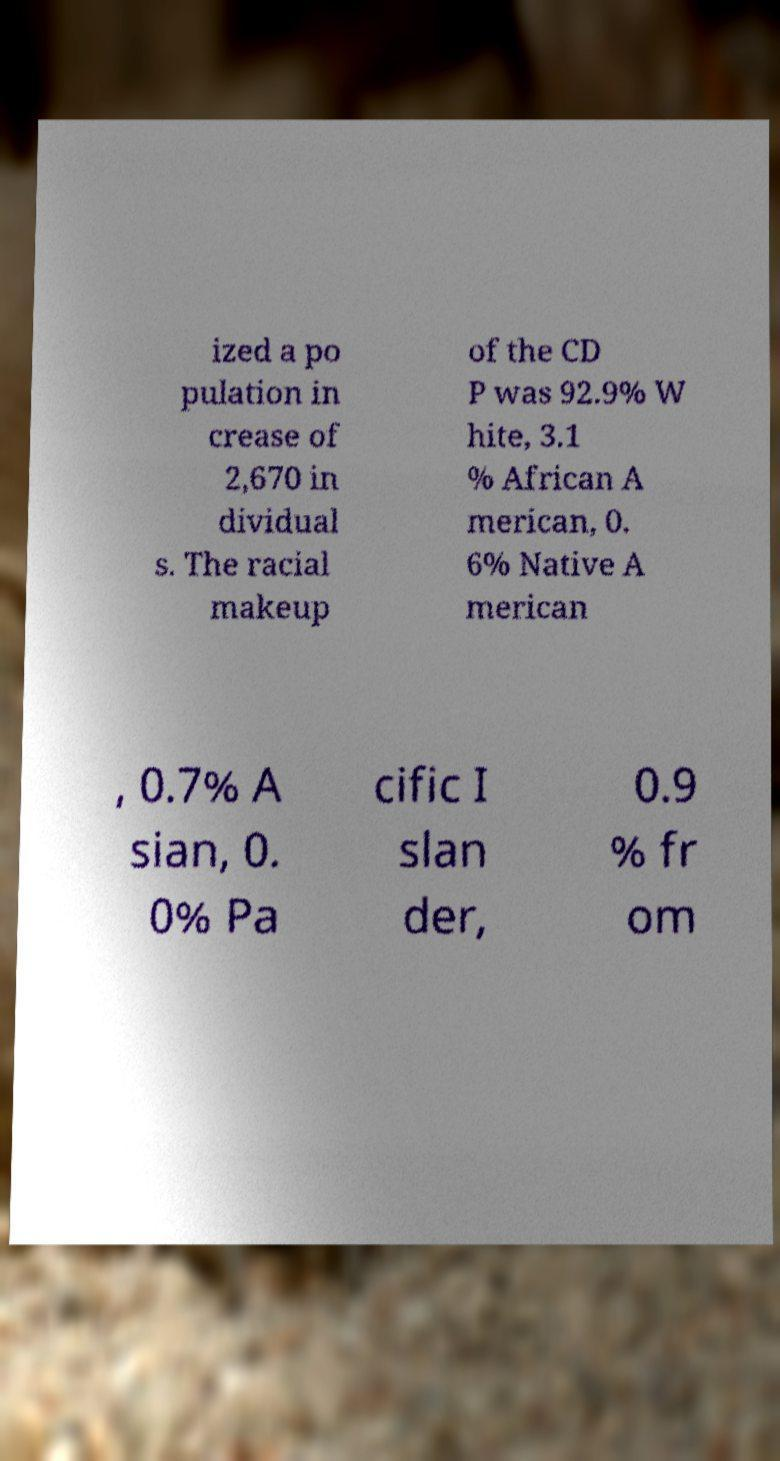Please read and relay the text visible in this image. What does it say? ized a po pulation in crease of 2,670 in dividual s. The racial makeup of the CD P was 92.9% W hite, 3.1 % African A merican, 0. 6% Native A merican , 0.7% A sian, 0. 0% Pa cific I slan der, 0.9 % fr om 